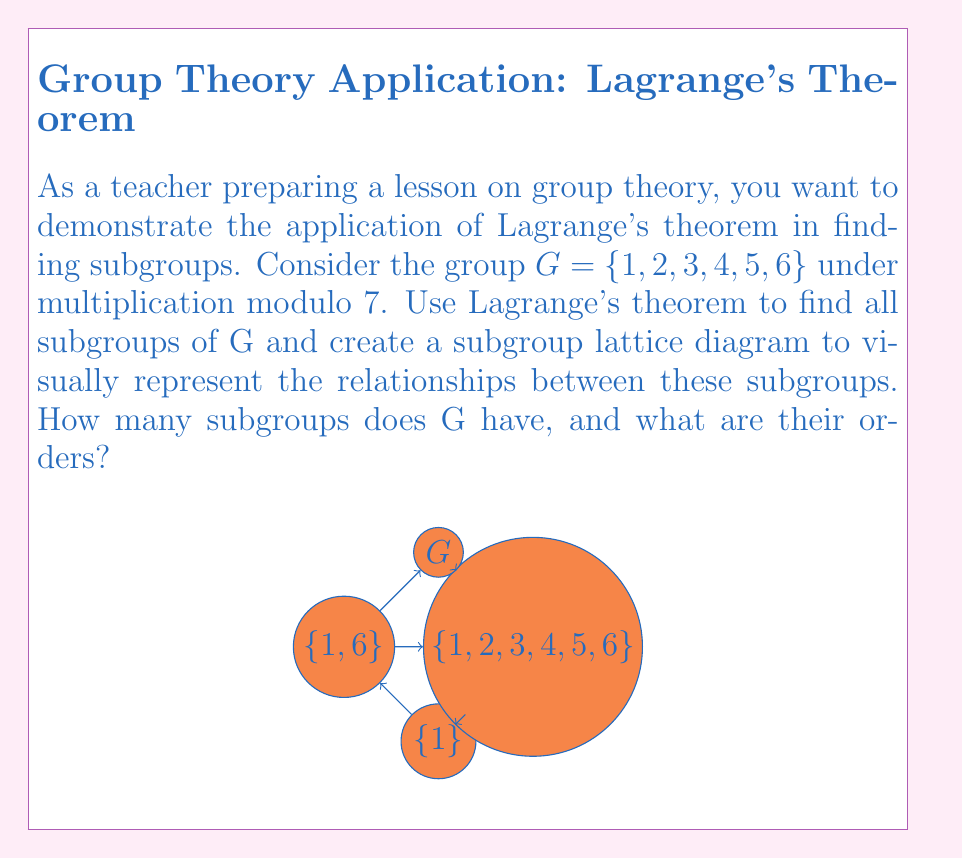What is the answer to this math problem? Let's approach this step-by-step:

1) First, we need to determine the order of G. 
   $|G| = 6$

2) By Lagrange's theorem, the order of any subgroup must divide the order of G. 
   The divisors of 6 are 1, 2, 3, and 6.

3) Now, let's find the subgroups for each possible order:

   a) Order 1: The trivial subgroup $\{1\}$ always exists.

   b) Order 2: We need to check elements of order 2.
      $2^2 \equiv 4 \pmod{7}$, $3^2 \equiv 2 \pmod{7}$, $4^2 \equiv 2 \pmod{7}$, $5^2 \equiv 4 \pmod{7}$, $6^2 \equiv 1 \pmod{7}$
      Therefore, $\{1,6\}$ is a subgroup of order 2.

   c) Order 3: We need to check elements of order 3.
      $2^3 \equiv 1 \pmod{7}$, $4^3 \equiv 1 \pmod{7}$
      Therefore, $\{1,2,4\}$ is a subgroup of order 3.

   d) Order 6: The entire group G is always a subgroup of itself.

4) To create the subgroup lattice diagram, we arrange the subgroups by order and connect them based on inclusion. The diagram is shown in the question.

5) Counting the subgroups:
   We have one subgroup each of orders 1, 2, 3, and 6.
   Total number of subgroups: 1 + 1 + 1 + 1 = 4

Therefore, G has 4 subgroups with orders 1, 2, 3, and 6.
Answer: 4 subgroups: $\{1\}$, $\{1,6\}$, $\{1,2,4\}$, and $G$, with orders 1, 2, 3, and 6 respectively. 